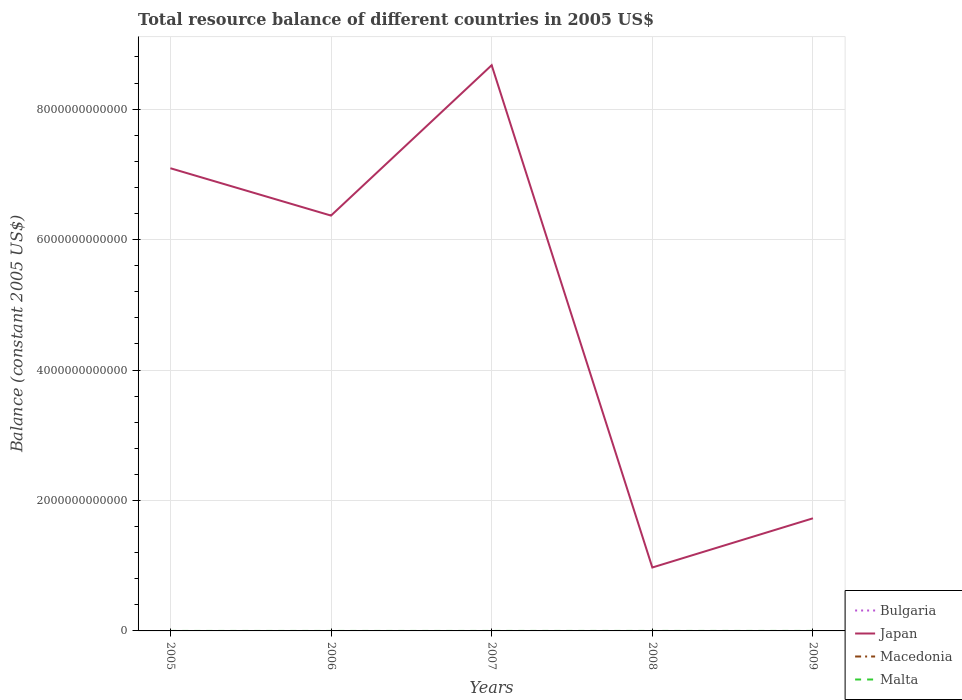How many different coloured lines are there?
Ensure brevity in your answer.  1. Is the number of lines equal to the number of legend labels?
Offer a very short reply. No. Across all years, what is the maximum total resource balance in Macedonia?
Your answer should be very brief. 0. What is the total total resource balance in Japan in the graph?
Ensure brevity in your answer.  4.64e+12. What is the difference between the highest and the second highest total resource balance in Japan?
Offer a very short reply. 7.70e+12. What is the difference between two consecutive major ticks on the Y-axis?
Keep it short and to the point. 2.00e+12. Are the values on the major ticks of Y-axis written in scientific E-notation?
Keep it short and to the point. No. Does the graph contain grids?
Your answer should be very brief. Yes. How are the legend labels stacked?
Offer a very short reply. Vertical. What is the title of the graph?
Keep it short and to the point. Total resource balance of different countries in 2005 US$. Does "Turkmenistan" appear as one of the legend labels in the graph?
Make the answer very short. No. What is the label or title of the X-axis?
Offer a very short reply. Years. What is the label or title of the Y-axis?
Offer a very short reply. Balance (constant 2005 US$). What is the Balance (constant 2005 US$) of Bulgaria in 2005?
Offer a very short reply. 0. What is the Balance (constant 2005 US$) of Japan in 2005?
Ensure brevity in your answer.  7.09e+12. What is the Balance (constant 2005 US$) of Macedonia in 2005?
Offer a terse response. 0. What is the Balance (constant 2005 US$) of Bulgaria in 2006?
Offer a terse response. 0. What is the Balance (constant 2005 US$) in Japan in 2006?
Keep it short and to the point. 6.37e+12. What is the Balance (constant 2005 US$) of Macedonia in 2006?
Your answer should be compact. 0. What is the Balance (constant 2005 US$) in Japan in 2007?
Provide a succinct answer. 8.67e+12. What is the Balance (constant 2005 US$) of Malta in 2007?
Ensure brevity in your answer.  0. What is the Balance (constant 2005 US$) in Bulgaria in 2008?
Your answer should be very brief. 0. What is the Balance (constant 2005 US$) of Japan in 2008?
Your answer should be compact. 9.72e+11. What is the Balance (constant 2005 US$) of Macedonia in 2008?
Your response must be concise. 0. What is the Balance (constant 2005 US$) of Malta in 2008?
Give a very brief answer. 0. What is the Balance (constant 2005 US$) in Bulgaria in 2009?
Keep it short and to the point. 0. What is the Balance (constant 2005 US$) of Japan in 2009?
Offer a terse response. 1.73e+12. What is the Balance (constant 2005 US$) of Macedonia in 2009?
Offer a very short reply. 0. What is the Balance (constant 2005 US$) of Malta in 2009?
Your response must be concise. 0. Across all years, what is the maximum Balance (constant 2005 US$) in Japan?
Offer a terse response. 8.67e+12. Across all years, what is the minimum Balance (constant 2005 US$) of Japan?
Provide a succinct answer. 9.72e+11. What is the total Balance (constant 2005 US$) in Japan in the graph?
Provide a short and direct response. 2.48e+13. What is the total Balance (constant 2005 US$) of Malta in the graph?
Provide a short and direct response. 0. What is the difference between the Balance (constant 2005 US$) in Japan in 2005 and that in 2006?
Keep it short and to the point. 7.26e+11. What is the difference between the Balance (constant 2005 US$) in Japan in 2005 and that in 2007?
Make the answer very short. -1.58e+12. What is the difference between the Balance (constant 2005 US$) in Japan in 2005 and that in 2008?
Make the answer very short. 6.12e+12. What is the difference between the Balance (constant 2005 US$) in Japan in 2005 and that in 2009?
Keep it short and to the point. 5.37e+12. What is the difference between the Balance (constant 2005 US$) of Japan in 2006 and that in 2007?
Ensure brevity in your answer.  -2.31e+12. What is the difference between the Balance (constant 2005 US$) in Japan in 2006 and that in 2008?
Give a very brief answer. 5.40e+12. What is the difference between the Balance (constant 2005 US$) in Japan in 2006 and that in 2009?
Offer a terse response. 4.64e+12. What is the difference between the Balance (constant 2005 US$) of Japan in 2007 and that in 2008?
Provide a succinct answer. 7.70e+12. What is the difference between the Balance (constant 2005 US$) of Japan in 2007 and that in 2009?
Offer a terse response. 6.95e+12. What is the difference between the Balance (constant 2005 US$) of Japan in 2008 and that in 2009?
Your answer should be compact. -7.54e+11. What is the average Balance (constant 2005 US$) of Bulgaria per year?
Make the answer very short. 0. What is the average Balance (constant 2005 US$) of Japan per year?
Provide a short and direct response. 4.97e+12. What is the average Balance (constant 2005 US$) in Malta per year?
Keep it short and to the point. 0. What is the ratio of the Balance (constant 2005 US$) of Japan in 2005 to that in 2006?
Provide a short and direct response. 1.11. What is the ratio of the Balance (constant 2005 US$) of Japan in 2005 to that in 2007?
Your answer should be very brief. 0.82. What is the ratio of the Balance (constant 2005 US$) in Japan in 2005 to that in 2008?
Give a very brief answer. 7.29. What is the ratio of the Balance (constant 2005 US$) of Japan in 2005 to that in 2009?
Provide a succinct answer. 4.11. What is the ratio of the Balance (constant 2005 US$) in Japan in 2006 to that in 2007?
Ensure brevity in your answer.  0.73. What is the ratio of the Balance (constant 2005 US$) of Japan in 2006 to that in 2008?
Your answer should be very brief. 6.55. What is the ratio of the Balance (constant 2005 US$) of Japan in 2006 to that in 2009?
Offer a terse response. 3.69. What is the ratio of the Balance (constant 2005 US$) in Japan in 2007 to that in 2008?
Give a very brief answer. 8.92. What is the ratio of the Balance (constant 2005 US$) of Japan in 2007 to that in 2009?
Your answer should be compact. 5.02. What is the ratio of the Balance (constant 2005 US$) of Japan in 2008 to that in 2009?
Keep it short and to the point. 0.56. What is the difference between the highest and the second highest Balance (constant 2005 US$) in Japan?
Keep it short and to the point. 1.58e+12. What is the difference between the highest and the lowest Balance (constant 2005 US$) in Japan?
Offer a very short reply. 7.70e+12. 